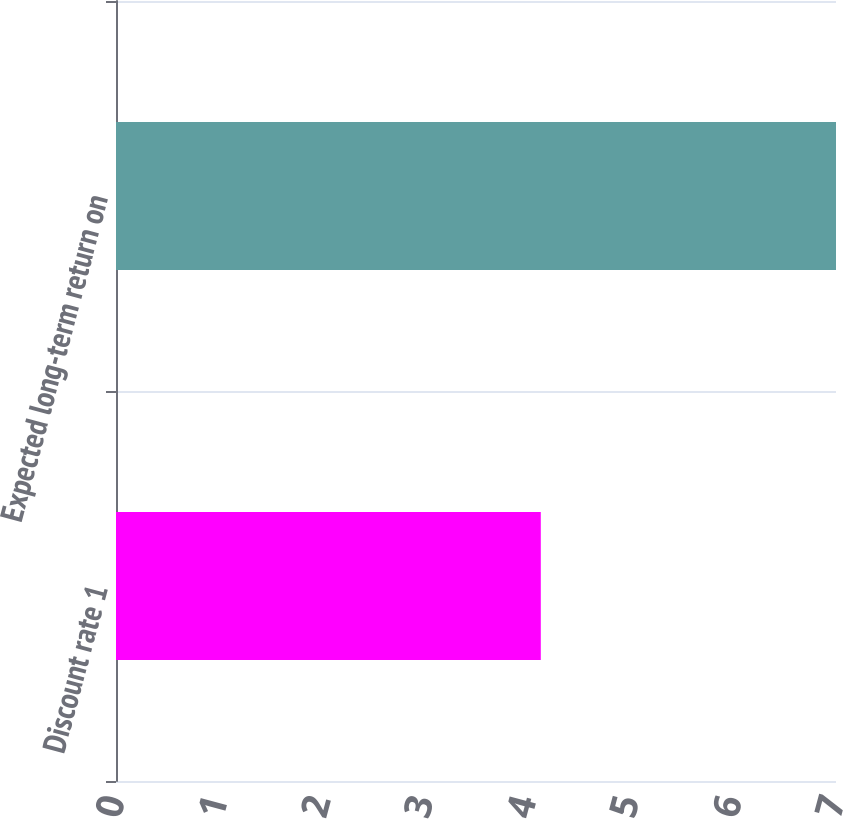Convert chart to OTSL. <chart><loc_0><loc_0><loc_500><loc_500><bar_chart><fcel>Discount rate 1<fcel>Expected long-term return on<nl><fcel>4.13<fcel>7<nl></chart> 